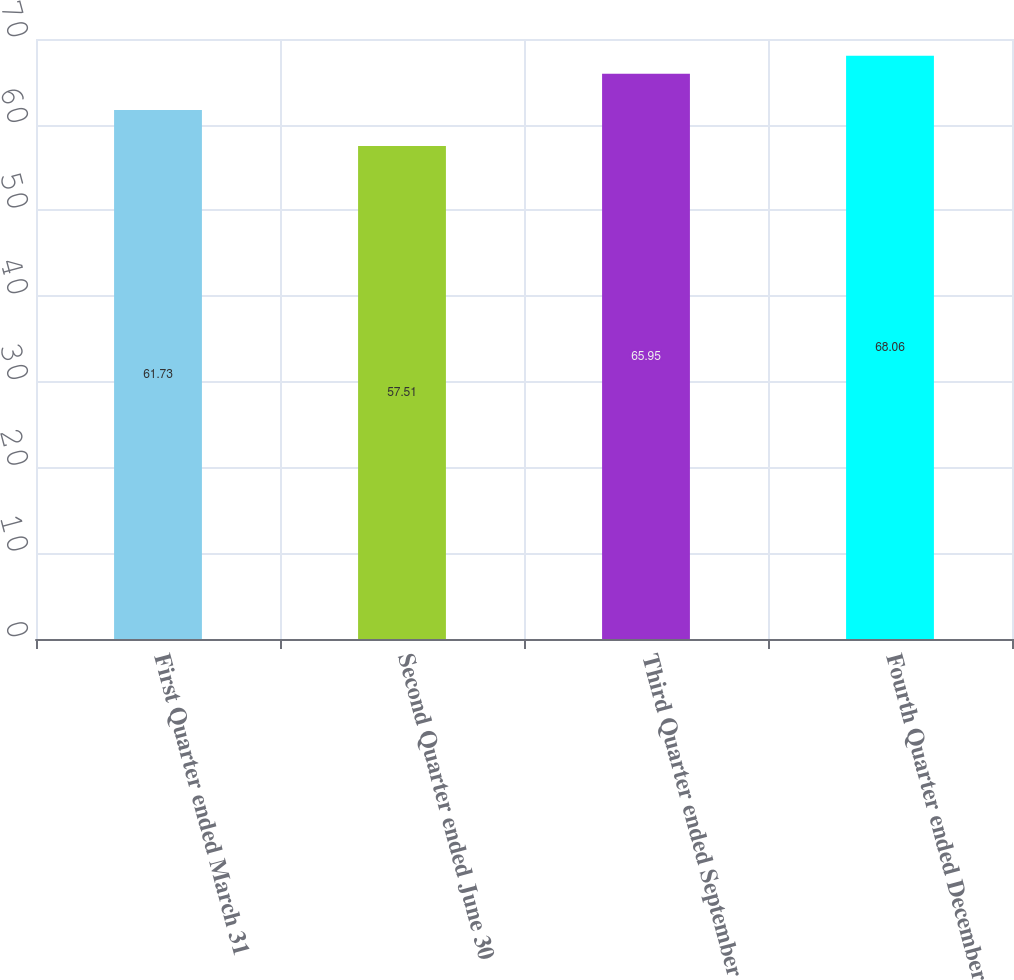Convert chart. <chart><loc_0><loc_0><loc_500><loc_500><bar_chart><fcel>First Quarter ended March 31<fcel>Second Quarter ended June 30<fcel>Third Quarter ended September<fcel>Fourth Quarter ended December<nl><fcel>61.73<fcel>57.51<fcel>65.95<fcel>68.06<nl></chart> 